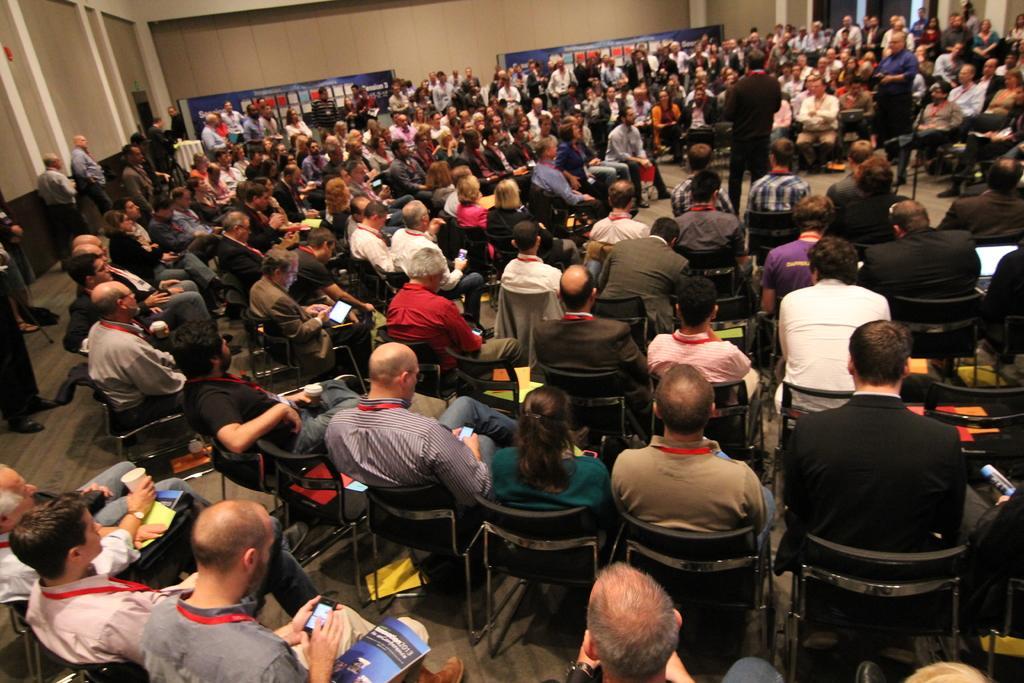Describe this image in one or two sentences. Here we can see many people are sitting on the chairs on the floor and among them few are holding mobiles in their hands and a man is holding a cup in his hand and there are laptops and books on few person's legs and there is a man standing in the middle. In the background we can see wall,hoardings and few persons are standing on the floor. 